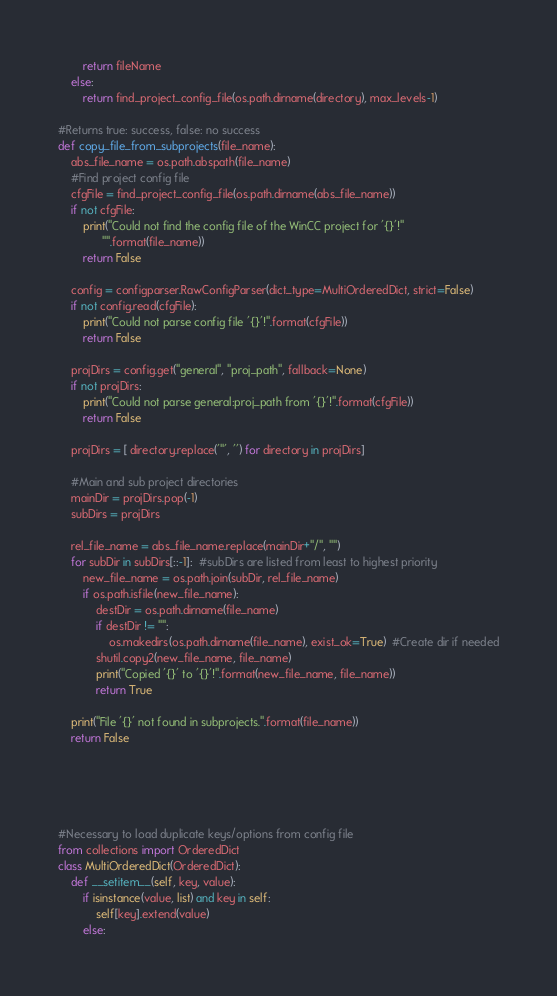<code> <loc_0><loc_0><loc_500><loc_500><_Python_>        return fileName
    else:
        return find_project_config_file(os.path.dirname(directory), max_levels-1)

#Returns true: success, false: no success
def copy_file_from_subprojects(file_name):
    abs_file_name = os.path.abspath(file_name)
    #Find project config file
    cfgFile = find_project_config_file(os.path.dirname(abs_file_name))
    if not cfgFile:
        print("Could not find the config file of the WinCC project for '{}'!"
              "".format(file_name))
        return False

    config = configparser.RawConfigParser(dict_type=MultiOrderedDict, strict=False)
    if not config.read(cfgFile):
        print("Could not parse config file '{}'!".format(cfgFile))
        return False

    projDirs = config.get("general", "proj_path", fallback=None)
    if not projDirs:
        print("Could not parse general:proj_path from '{}'!".format(cfgFile))
        return False

    projDirs = [ directory.replace('"', '') for directory in projDirs]

    #Main and sub project directories
    mainDir = projDirs.pop(-1)
    subDirs = projDirs

    rel_file_name = abs_file_name.replace(mainDir+"/", "")
    for subDir in subDirs[::-1]:  #subDirs are listed from least to highest priority
        new_file_name = os.path.join(subDir, rel_file_name)
        if os.path.isfile(new_file_name):
            destDir = os.path.dirname(file_name)
            if destDir != "":
                os.makedirs(os.path.dirname(file_name), exist_ok=True)  #Create dir if needed
            shutil.copy2(new_file_name, file_name)
            print("Copied '{}' to '{}'!".format(new_file_name, file_name))
            return True

    print("File '{}' not found in subprojects.".format(file_name))
    return False





#Necessary to load duplicate keys/options from config file
from collections import OrderedDict
class MultiOrderedDict(OrderedDict):
    def __setitem__(self, key, value):
        if isinstance(value, list) and key in self:
            self[key].extend(value)
        else:</code> 